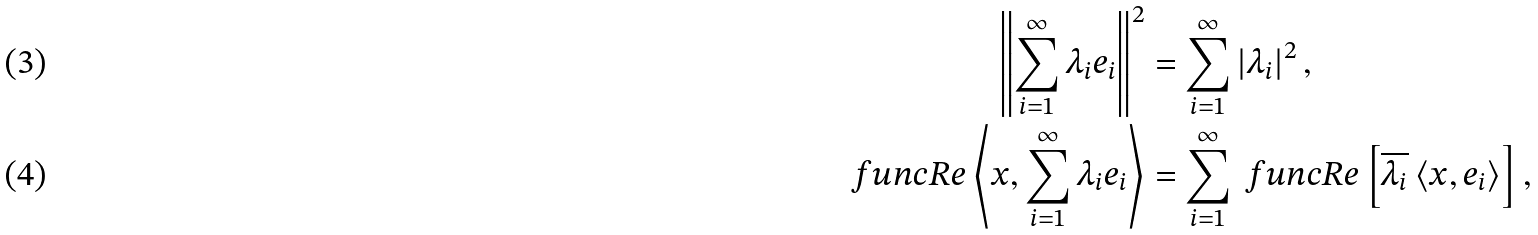Convert formula to latex. <formula><loc_0><loc_0><loc_500><loc_500>\left \| \sum _ { i = 1 } ^ { \infty } \lambda _ { i } e _ { i } \right \| ^ { 2 } & = \sum _ { i = 1 } ^ { \infty } \left | \lambda _ { i } \right | ^ { 2 } , \\ \ f u n c { R e } \left \langle x , \sum _ { i = 1 } ^ { \infty } \lambda _ { i } e _ { i } \right \rangle & = \sum _ { i = 1 } ^ { \infty } \ f u n c { R e } \left [ \overline { \lambda _ { i } } \left \langle x , e _ { i } \right \rangle \right ] ,</formula> 